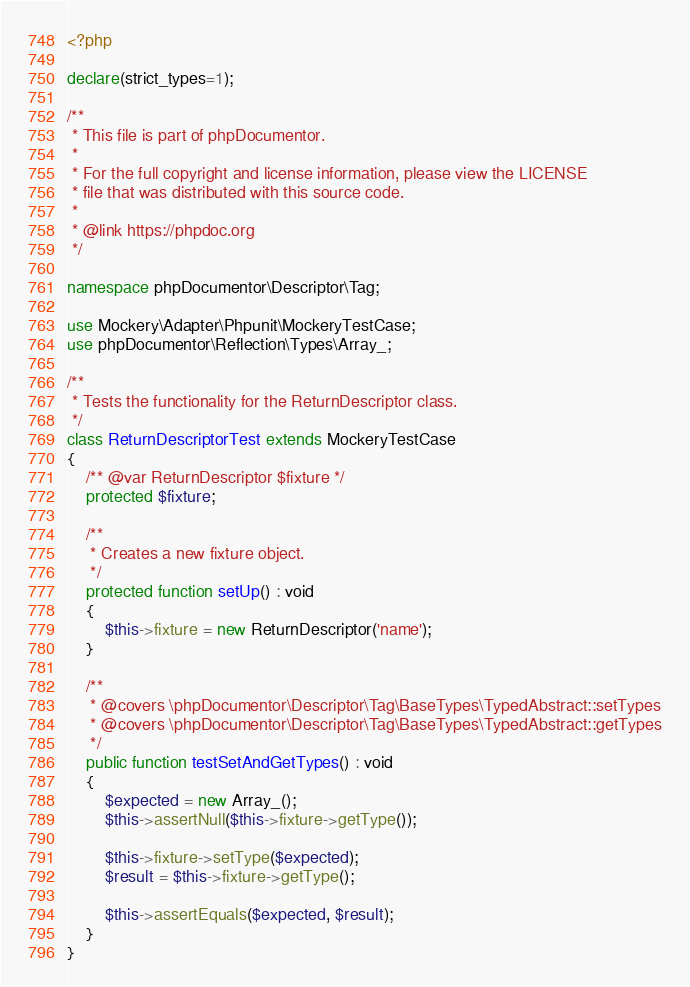<code> <loc_0><loc_0><loc_500><loc_500><_PHP_><?php

declare(strict_types=1);

/**
 * This file is part of phpDocumentor.
 *
 * For the full copyright and license information, please view the LICENSE
 * file that was distributed with this source code.
 *
 * @link https://phpdoc.org
 */

namespace phpDocumentor\Descriptor\Tag;

use Mockery\Adapter\Phpunit\MockeryTestCase;
use phpDocumentor\Reflection\Types\Array_;

/**
 * Tests the functionality for the ReturnDescriptor class.
 */
class ReturnDescriptorTest extends MockeryTestCase
{
    /** @var ReturnDescriptor $fixture */
    protected $fixture;

    /**
     * Creates a new fixture object.
     */
    protected function setUp() : void
    {
        $this->fixture = new ReturnDescriptor('name');
    }

    /**
     * @covers \phpDocumentor\Descriptor\Tag\BaseTypes\TypedAbstract::setTypes
     * @covers \phpDocumentor\Descriptor\Tag\BaseTypes\TypedAbstract::getTypes
     */
    public function testSetAndGetTypes() : void
    {
        $expected = new Array_();
        $this->assertNull($this->fixture->getType());

        $this->fixture->setType($expected);
        $result = $this->fixture->getType();

        $this->assertEquals($expected, $result);
    }
}
</code> 